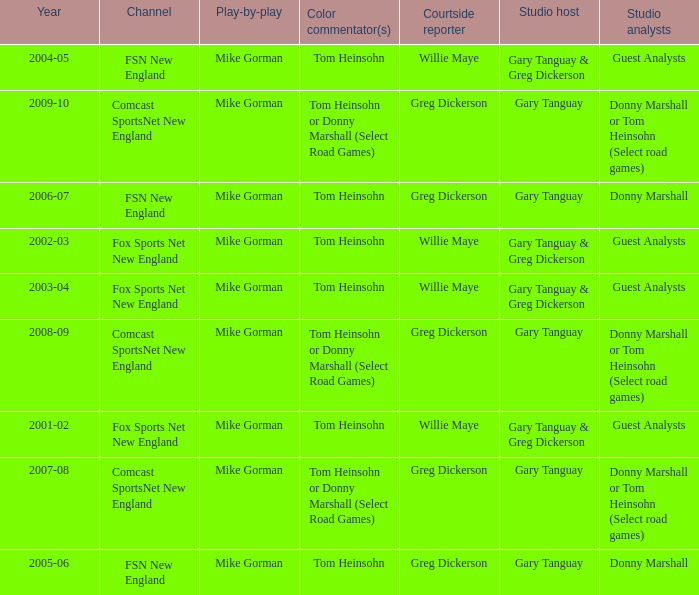How many channels were the games shown on in 2001-02? 1.0. 